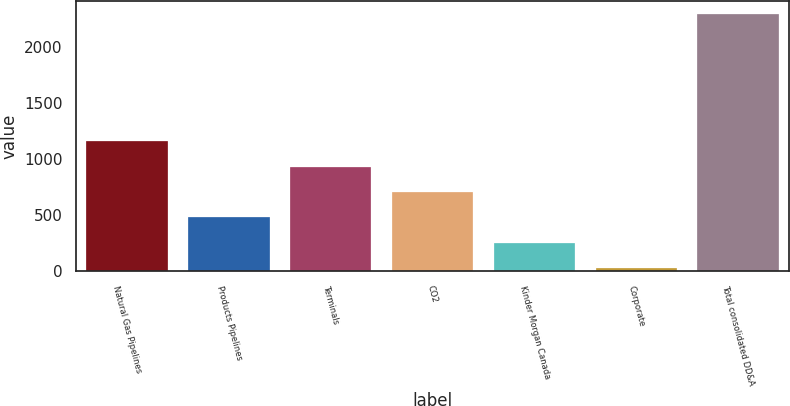Convert chart to OTSL. <chart><loc_0><loc_0><loc_500><loc_500><bar_chart><fcel>Natural Gas Pipelines<fcel>Products Pipelines<fcel>Terminals<fcel>CO2<fcel>Kinder Morgan Canada<fcel>Corporate<fcel>Total consolidated DD&A<nl><fcel>1161<fcel>479.4<fcel>933.8<fcel>706.6<fcel>252.2<fcel>25<fcel>2297<nl></chart> 